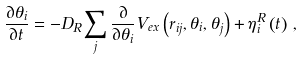Convert formula to latex. <formula><loc_0><loc_0><loc_500><loc_500>\frac { \partial \theta _ { i } } { \partial t } = - D _ { R } \sum _ { j } \frac { \partial } { \partial \theta _ { i } } V _ { e x } \left ( { r } _ { i j } , \theta _ { i } , \theta _ { j } \right ) + \eta ^ { R } _ { i } \left ( t \right ) \, ,</formula> 